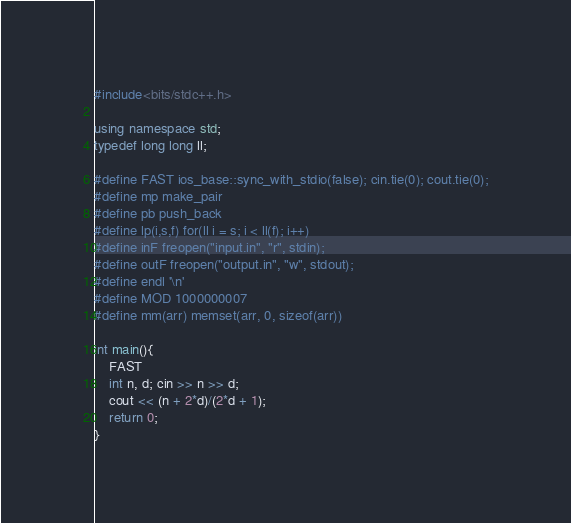<code> <loc_0><loc_0><loc_500><loc_500><_C++_>#include<bits/stdc++.h>

using namespace std;
typedef long long ll;

#define FAST ios_base::sync_with_stdio(false); cin.tie(0); cout.tie(0);
#define mp make_pair
#define pb push_back
#define lp(i,s,f) for(ll i = s; i < ll(f); i++)
#define inF freopen("input.in", "r", stdin);
#define outF freopen("output.in", "w", stdout);
#define endl '\n'
#define MOD 1000000007
#define mm(arr) memset(arr, 0, sizeof(arr))

int main(){
    FAST
    int n, d; cin >> n >> d;
    cout << (n + 2*d)/(2*d + 1);
    return 0;
}
</code> 